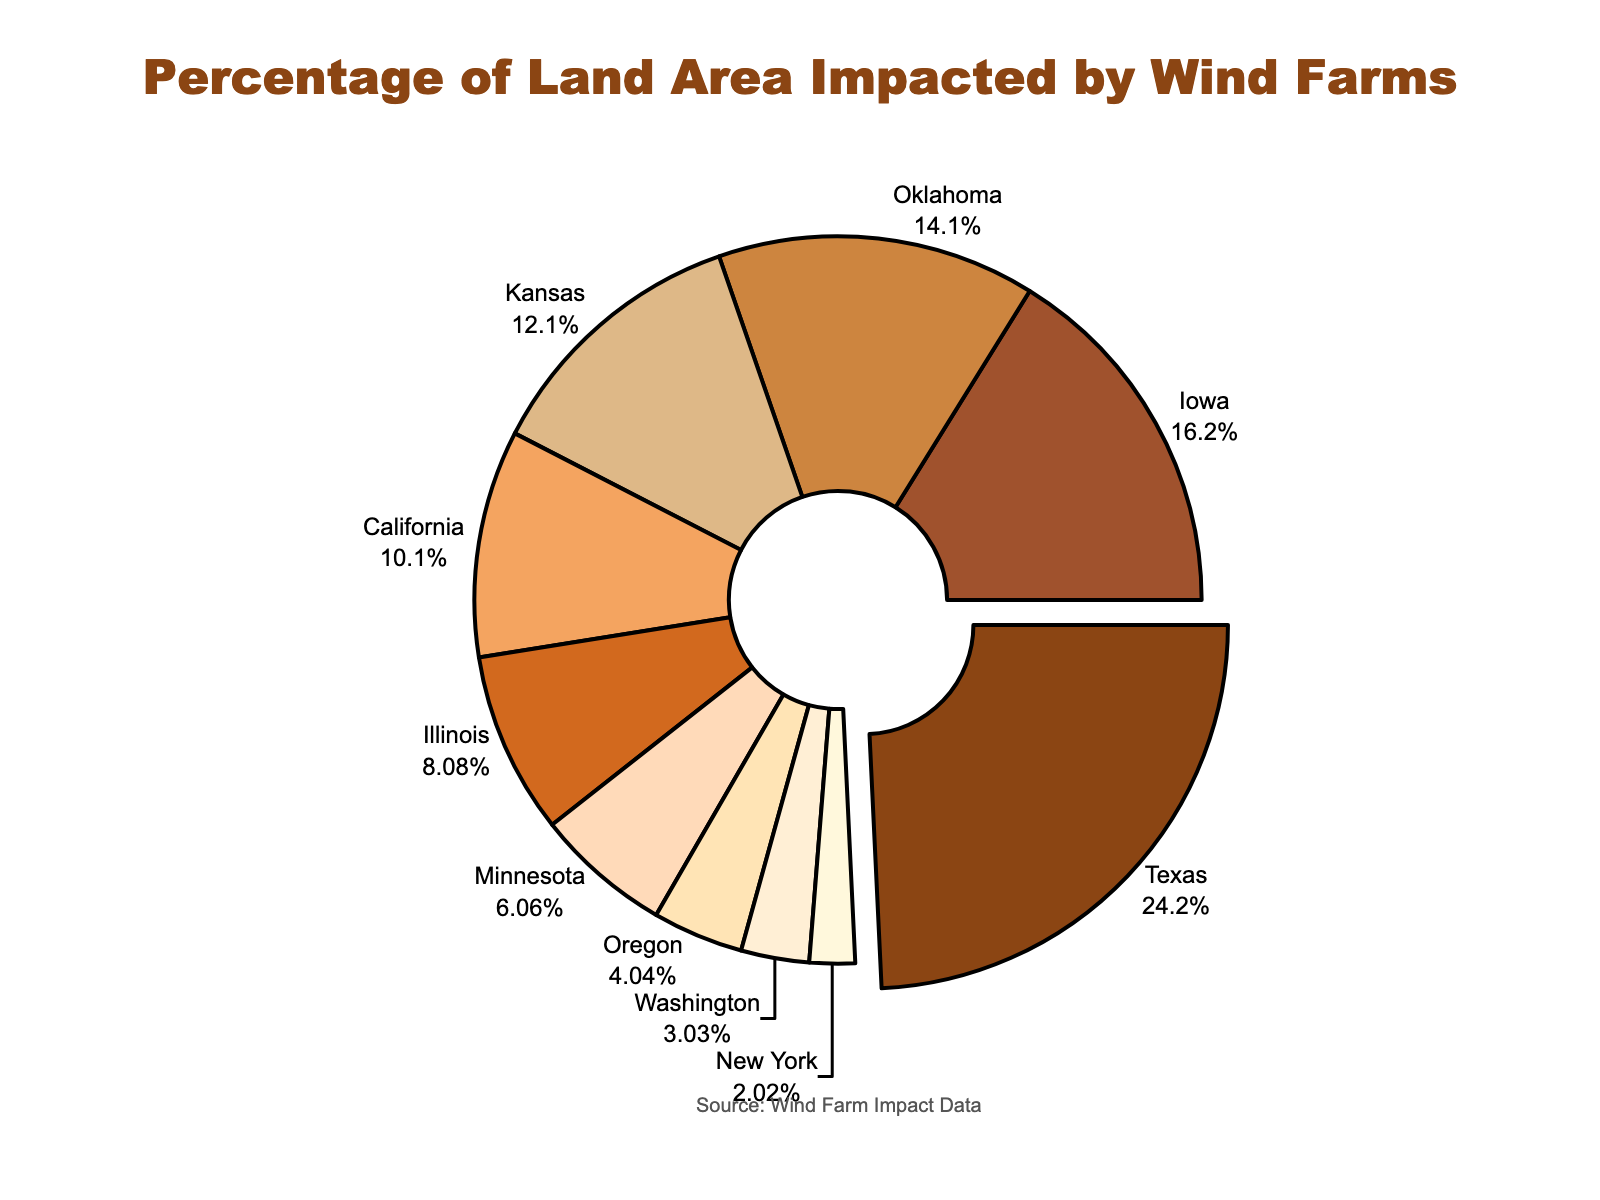Which region has the highest percentage of land area impacted by wind farms? The pie chart shows Texas with the largest segment pulled out from the center, indicating the highest percentage.
Answer: Texas Which three regions have the lowest percentage of land area impacted by wind farms? The smallest slices represent Washington, Oregon, and New York with percentages of 0.15, 0.2, and 0.1 respectively.
Answer: Washington, Oregon, New York What is the combined percentage of land area impacted by wind farms in Iowa and Oklahoma? The chart shows Iowa with 0.8% and Oklahoma with 0.7%, so adding these two percentages gives 0.8 + 0.7 = 1.5%.
Answer: 1.5% Which region has the most significant change when visually compared to California in terms of land area impacted? Texas has the largest percentage at 1.2%, whereas California has 0.5%, representing a significant difference of 1.2 - 0.5 = 0.7%.
Answer: Texas How does the percentage of land area impacted in Kansas compare to Iowa? Kansas has a 0.6% impact, while Iowa has a 0.8% impact, so Kansas has 0.2% less impact.
Answer: Iowa has a higher impact What is the average percentage of land area impacted by wind farms across all regions? Summing all percentages (1.2 + 0.8 + 0.7 + 0.6 + 0.5 + 0.4 + 0.3 + 0.2 + 0.15 + 0.1 = 4.95) and dividing by the number of regions (10) gives an average of 4.95 / 10 = 0.495%.
Answer: 0.495% By how much does the percentage of land area impacted in Texas exceed that in New York? Texas has a 1.2% impact, while New York has a 0.1% impact. The difference is 1.2 - 0.1 = 1.1%.
Answer: 1.1% Which color represents Minnesota in the pie chart? Minnesota is the seventh region, represented here by the seventh color in the specified color list, which is #FFDAB9 (Peach).
Answer: Peach (pale orange) What is the total percentage of land area impacted by wind farms in the states with less than 0.5% impact? Summing the percentages for Illinois (0.4), Minnesota (0.3), Oregon (0.2), Washington (0.15), and New York (0.1) gives 0.4 + 0.3 + 0.2 + 0.15 + 0.1 = 1.15%.
Answer: 1.15% 